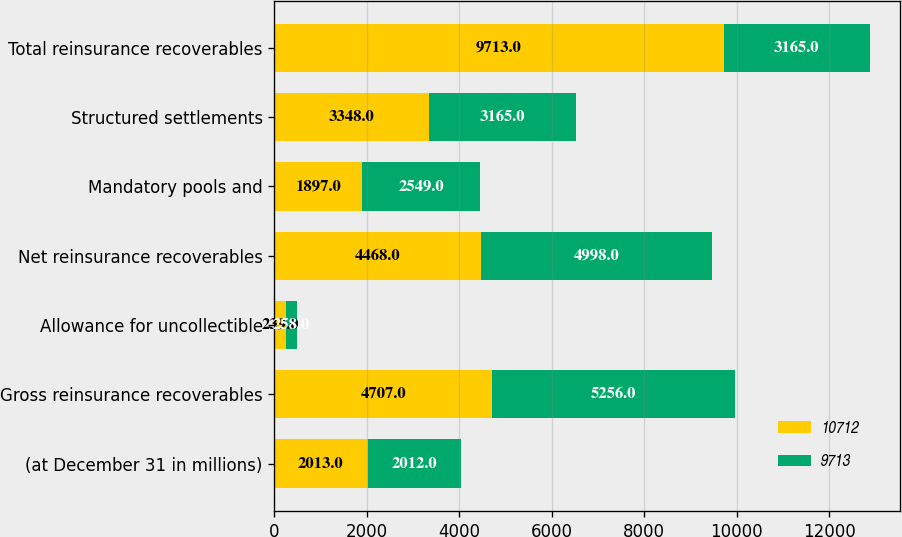Convert chart. <chart><loc_0><loc_0><loc_500><loc_500><stacked_bar_chart><ecel><fcel>(at December 31 in millions)<fcel>Gross reinsurance recoverables<fcel>Allowance for uncollectible<fcel>Net reinsurance recoverables<fcel>Mandatory pools and<fcel>Structured settlements<fcel>Total reinsurance recoverables<nl><fcel>10712<fcel>2013<fcel>4707<fcel>239<fcel>4468<fcel>1897<fcel>3348<fcel>9713<nl><fcel>9713<fcel>2012<fcel>5256<fcel>258<fcel>4998<fcel>2549<fcel>3165<fcel>3165<nl></chart> 